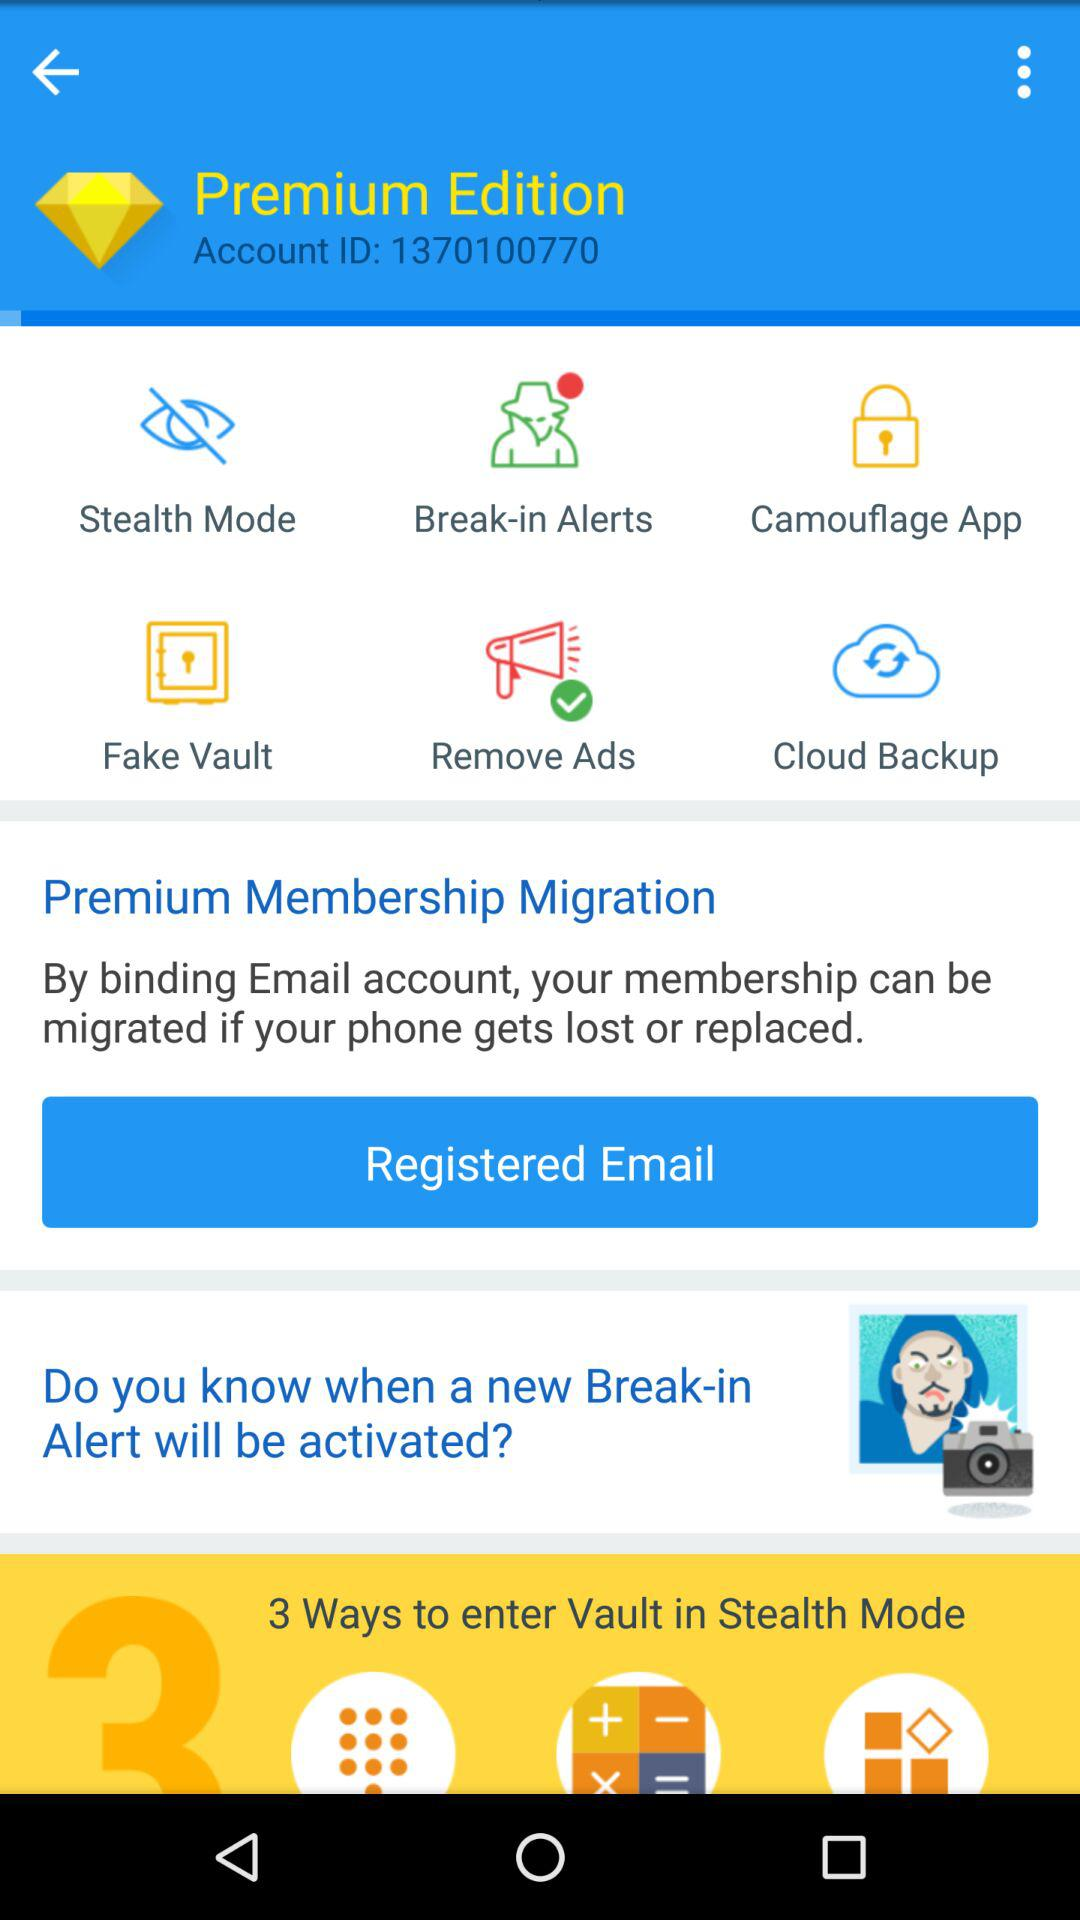What is the account ID? The account ID is 1370100770. 